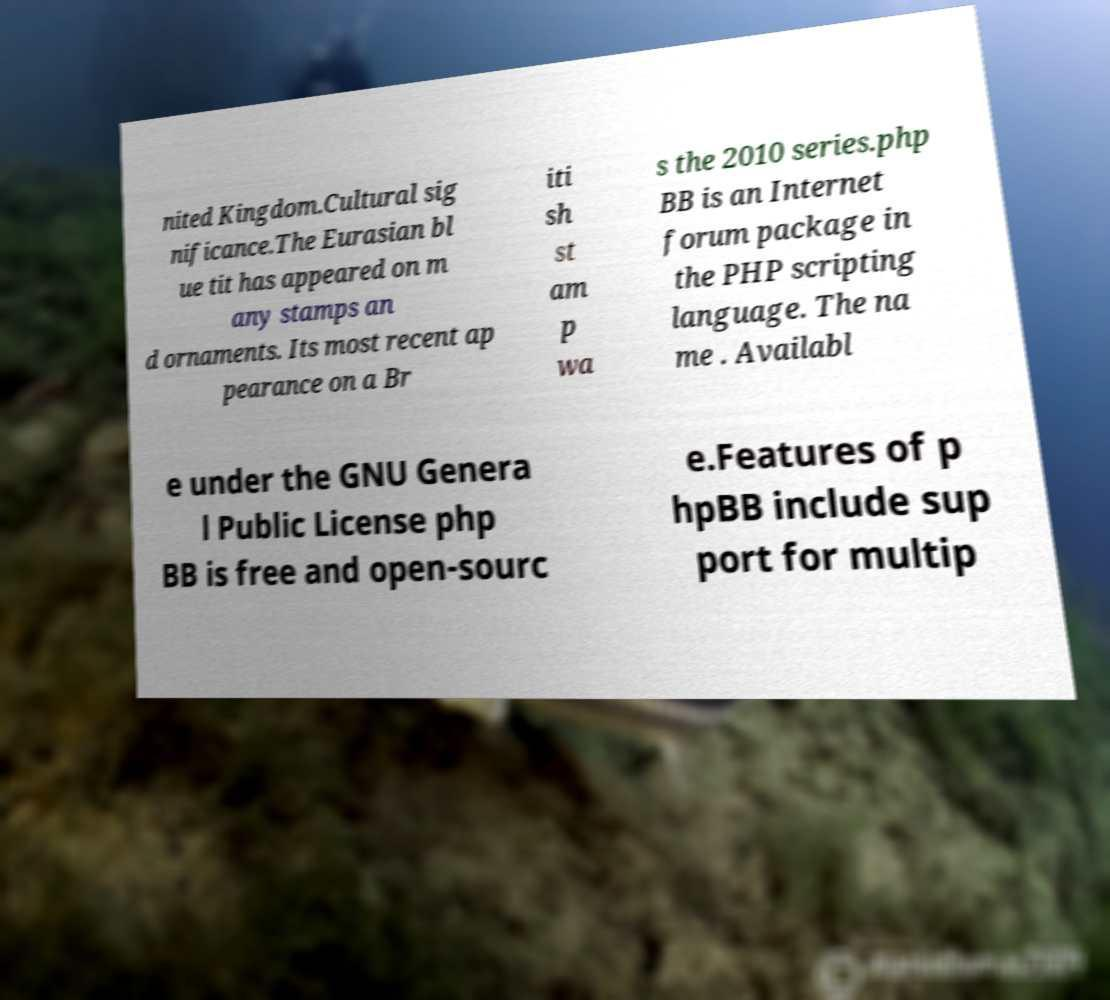Could you assist in decoding the text presented in this image and type it out clearly? nited Kingdom.Cultural sig nificance.The Eurasian bl ue tit has appeared on m any stamps an d ornaments. Its most recent ap pearance on a Br iti sh st am p wa s the 2010 series.php BB is an Internet forum package in the PHP scripting language. The na me . Availabl e under the GNU Genera l Public License php BB is free and open-sourc e.Features of p hpBB include sup port for multip 